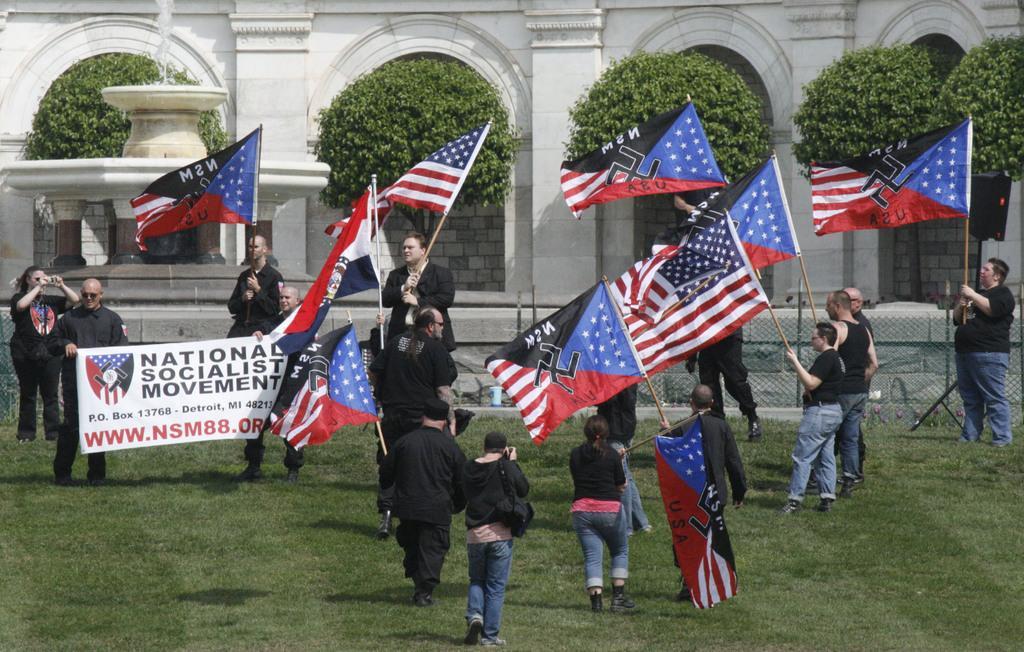How would you summarize this image in a sentence or two? In this image we can see a few people among them some are holding flags and some holding a poster with some text and image, we can see a woman standing and taking a picture, in the background, we can see a building with pillars and trees, also we can see the poles and fence. 